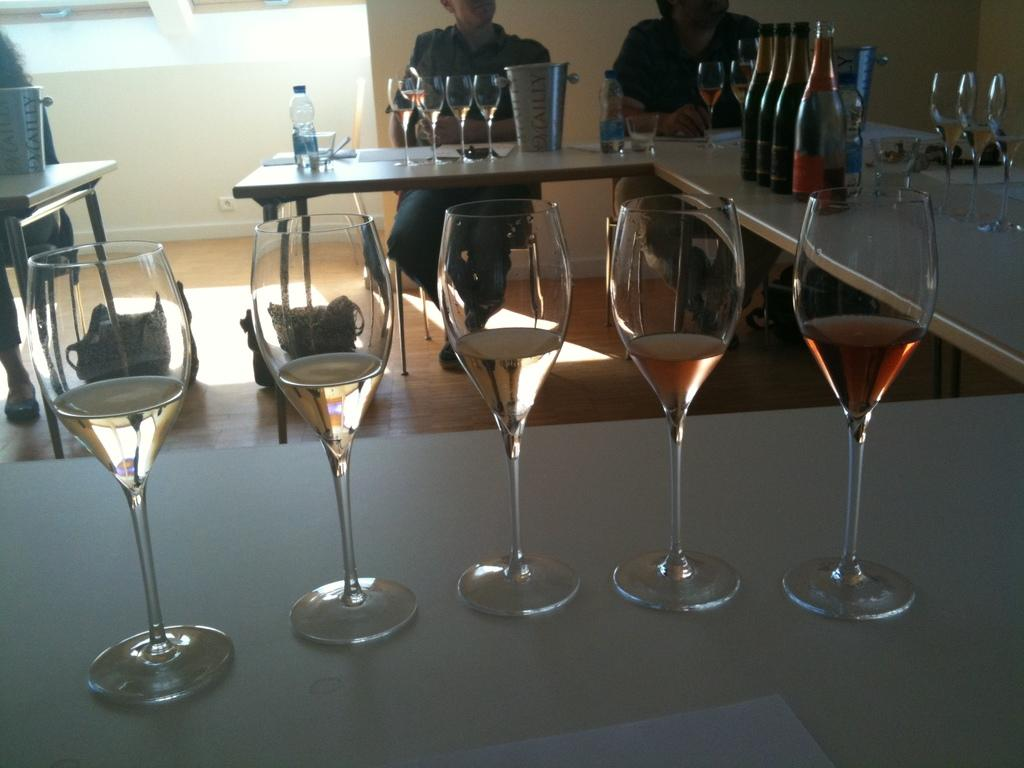How many people are in the image? There are two persons in the image. What are the persons doing in the image? The persons are sitting on a chair. Where is the chair located in relation to the table? The chair is in front of a table. What can be seen on the table in the image? There are glasses, glass bottles, and other objects on the table. What type of toys can be seen on the table in the image? There are no toys present on the table in the image. How many times do the persons touch the table in the image? The image does not show the persons touching the table, so it cannot be determined how many times they do so. 